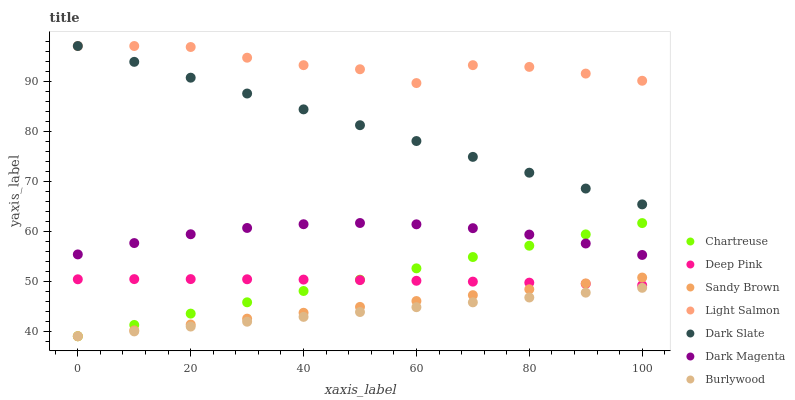Does Burlywood have the minimum area under the curve?
Answer yes or no. Yes. Does Light Salmon have the maximum area under the curve?
Answer yes or no. Yes. Does Deep Pink have the minimum area under the curve?
Answer yes or no. No. Does Deep Pink have the maximum area under the curve?
Answer yes or no. No. Is Burlywood the smoothest?
Answer yes or no. Yes. Is Light Salmon the roughest?
Answer yes or no. Yes. Is Deep Pink the smoothest?
Answer yes or no. No. Is Deep Pink the roughest?
Answer yes or no. No. Does Burlywood have the lowest value?
Answer yes or no. Yes. Does Deep Pink have the lowest value?
Answer yes or no. No. Does Dark Slate have the highest value?
Answer yes or no. Yes. Does Deep Pink have the highest value?
Answer yes or no. No. Is Burlywood less than Dark Slate?
Answer yes or no. Yes. Is Light Salmon greater than Deep Pink?
Answer yes or no. Yes. Does Deep Pink intersect Chartreuse?
Answer yes or no. Yes. Is Deep Pink less than Chartreuse?
Answer yes or no. No. Is Deep Pink greater than Chartreuse?
Answer yes or no. No. Does Burlywood intersect Dark Slate?
Answer yes or no. No. 